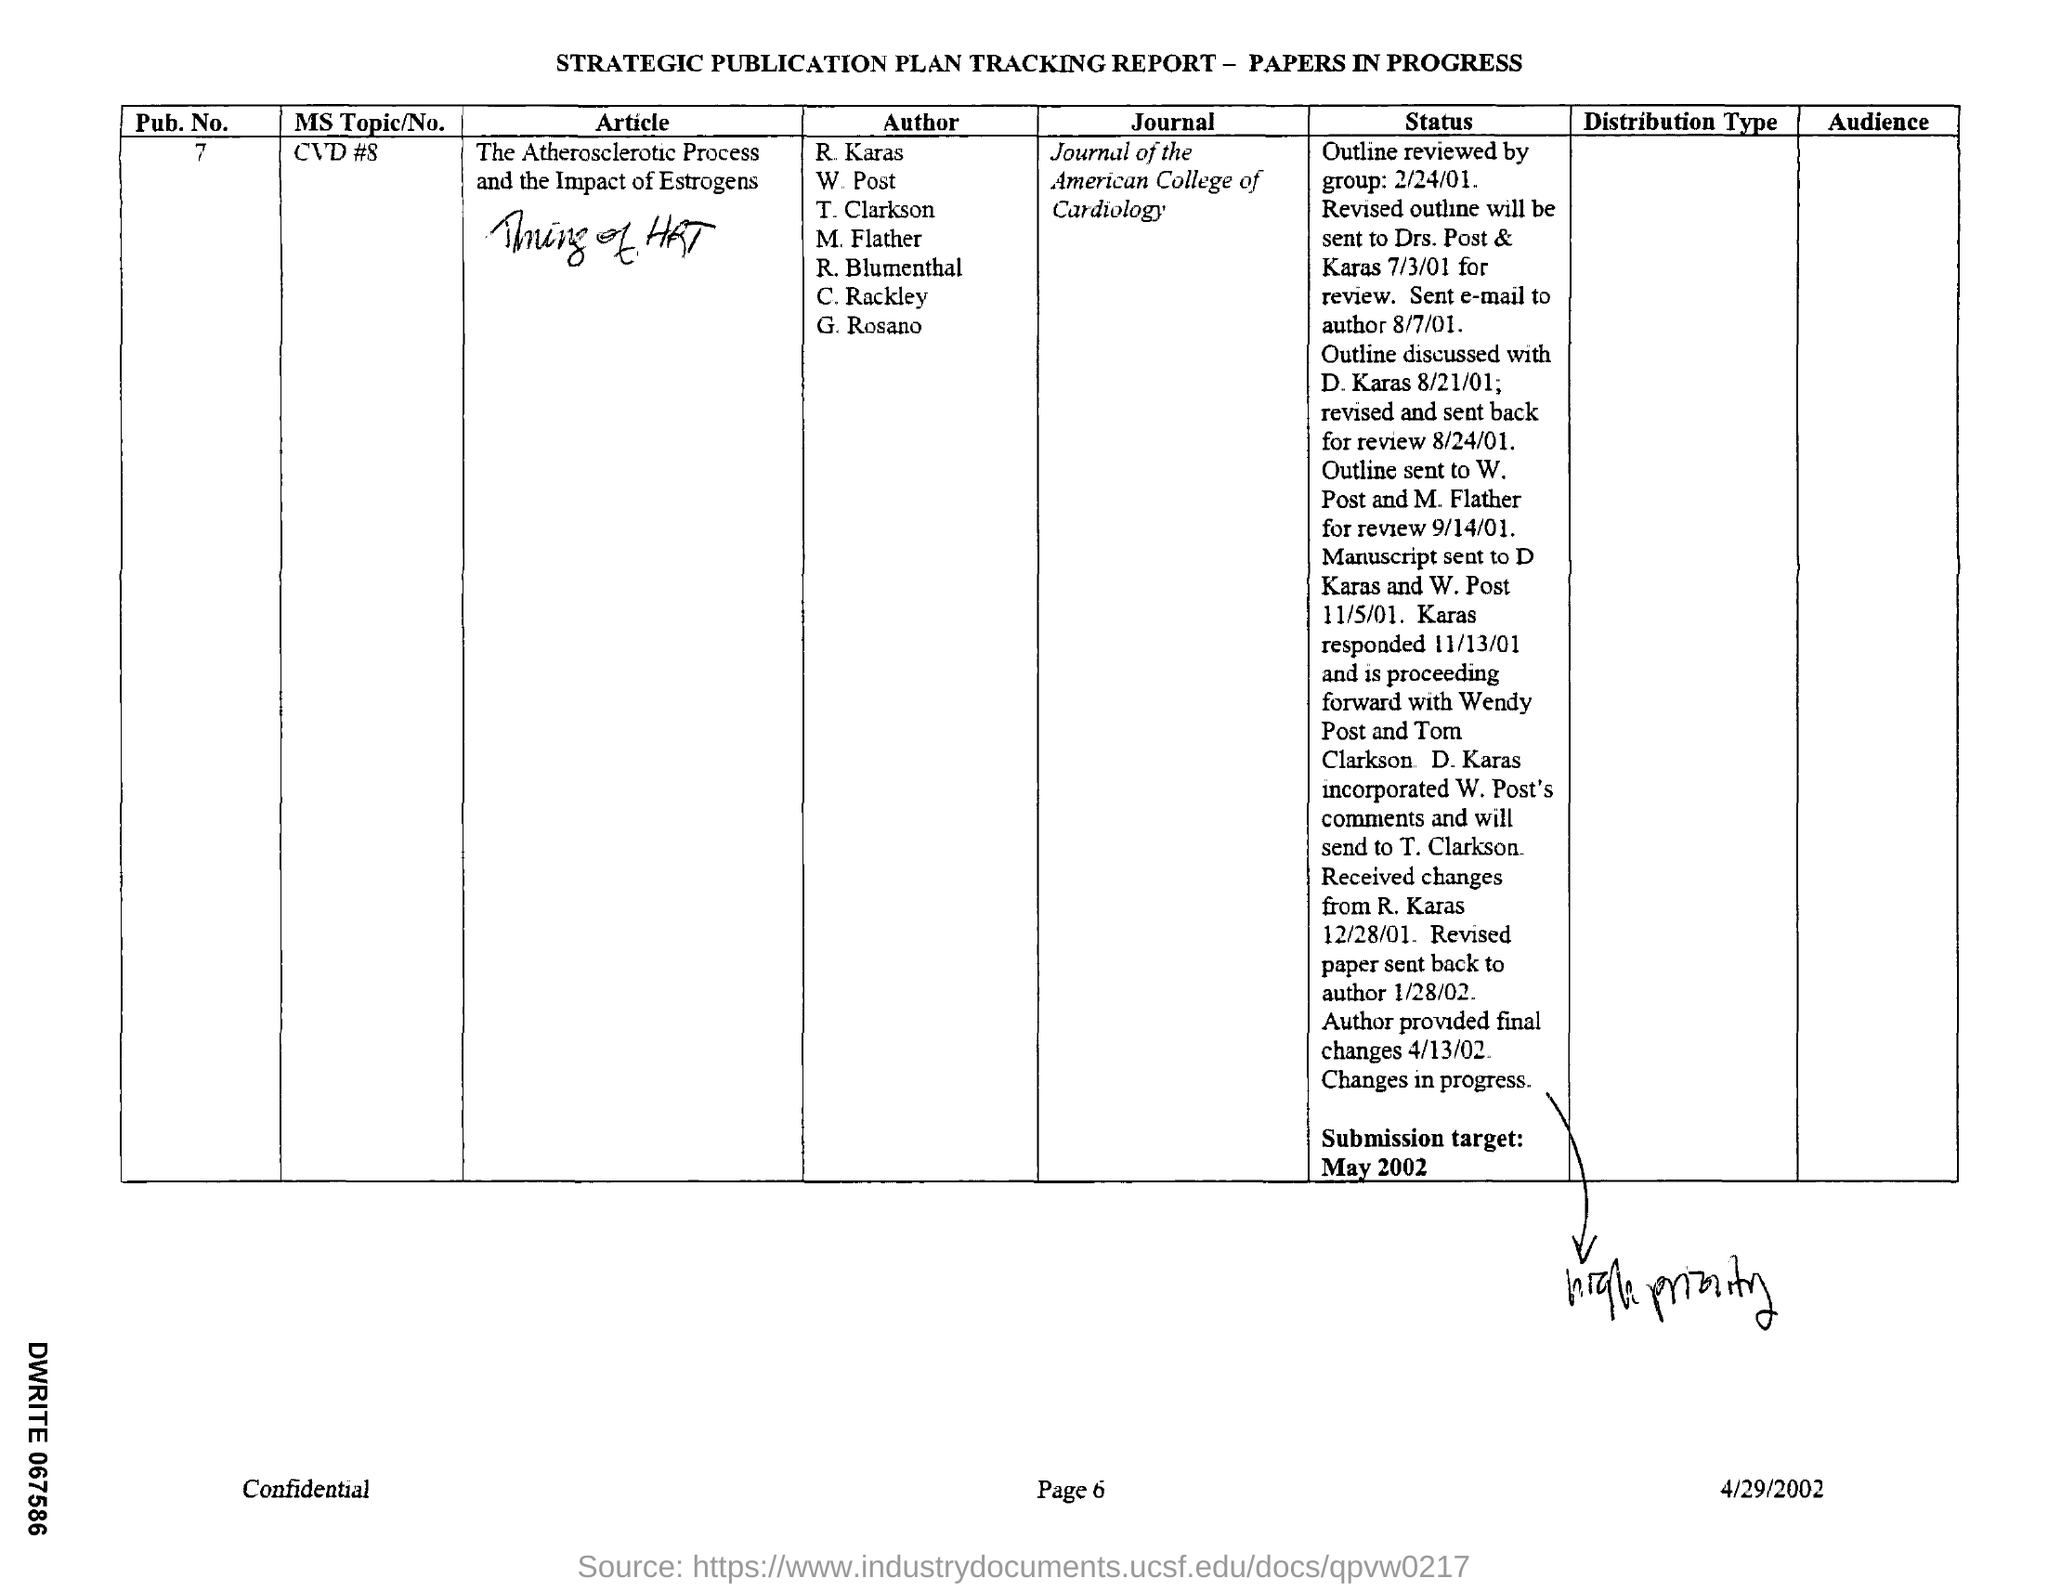What is the journal mentioned in the tracking report ?
Provide a succinct answer. Journal of the American college of cardiology. When is the submission target mentioned in the report ?
Provide a succinct answer. May 2002. What is the name of the article mentioned in the given report ?
Your answer should be very brief. The atherosclerotic process and the impact of estrogens. What is the pub .no. mentioned in the given tracking report ?
Your response must be concise. 7. What is ms topic/no mentioned in the given report ?
Your response must be concise. CVD #8. 